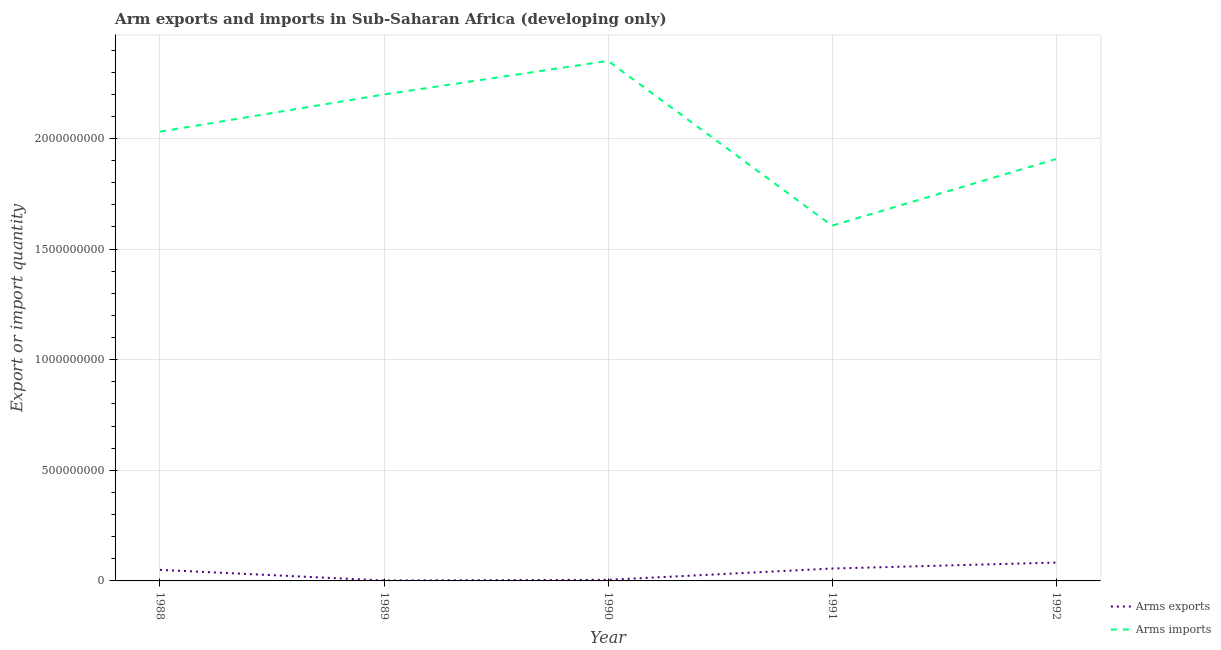Does the line corresponding to arms exports intersect with the line corresponding to arms imports?
Provide a succinct answer. No. Is the number of lines equal to the number of legend labels?
Offer a terse response. Yes. What is the arms exports in 1989?
Your response must be concise. 2.00e+06. Across all years, what is the maximum arms exports?
Keep it short and to the point. 8.30e+07. Across all years, what is the minimum arms imports?
Offer a very short reply. 1.61e+09. In which year was the arms imports maximum?
Make the answer very short. 1990. What is the total arms imports in the graph?
Provide a short and direct response. 1.01e+1. What is the difference between the arms exports in 1990 and that in 1991?
Your response must be concise. -5.10e+07. What is the difference between the arms exports in 1988 and the arms imports in 1990?
Keep it short and to the point. -2.30e+09. What is the average arms exports per year?
Keep it short and to the point. 3.92e+07. In the year 1989, what is the difference between the arms exports and arms imports?
Offer a terse response. -2.20e+09. What is the ratio of the arms exports in 1989 to that in 1991?
Your answer should be compact. 0.04. What is the difference between the highest and the second highest arms exports?
Keep it short and to the point. 2.70e+07. What is the difference between the highest and the lowest arms imports?
Offer a terse response. 7.45e+08. In how many years, is the arms imports greater than the average arms imports taken over all years?
Offer a very short reply. 3. Is the sum of the arms exports in 1988 and 1992 greater than the maximum arms imports across all years?
Offer a very short reply. No. How many lines are there?
Provide a short and direct response. 2. Are the values on the major ticks of Y-axis written in scientific E-notation?
Offer a terse response. No. How are the legend labels stacked?
Provide a short and direct response. Vertical. What is the title of the graph?
Provide a succinct answer. Arm exports and imports in Sub-Saharan Africa (developing only). What is the label or title of the X-axis?
Your answer should be compact. Year. What is the label or title of the Y-axis?
Your answer should be compact. Export or import quantity. What is the Export or import quantity in Arms imports in 1988?
Provide a short and direct response. 2.03e+09. What is the Export or import quantity in Arms imports in 1989?
Offer a terse response. 2.20e+09. What is the Export or import quantity in Arms imports in 1990?
Make the answer very short. 2.35e+09. What is the Export or import quantity in Arms exports in 1991?
Provide a succinct answer. 5.60e+07. What is the Export or import quantity of Arms imports in 1991?
Your answer should be compact. 1.61e+09. What is the Export or import quantity in Arms exports in 1992?
Give a very brief answer. 8.30e+07. What is the Export or import quantity of Arms imports in 1992?
Provide a succinct answer. 1.91e+09. Across all years, what is the maximum Export or import quantity in Arms exports?
Your answer should be very brief. 8.30e+07. Across all years, what is the maximum Export or import quantity of Arms imports?
Make the answer very short. 2.35e+09. Across all years, what is the minimum Export or import quantity in Arms imports?
Offer a terse response. 1.61e+09. What is the total Export or import quantity of Arms exports in the graph?
Ensure brevity in your answer.  1.96e+08. What is the total Export or import quantity in Arms imports in the graph?
Ensure brevity in your answer.  1.01e+1. What is the difference between the Export or import quantity of Arms exports in 1988 and that in 1989?
Your answer should be very brief. 4.80e+07. What is the difference between the Export or import quantity of Arms imports in 1988 and that in 1989?
Offer a terse response. -1.68e+08. What is the difference between the Export or import quantity of Arms exports in 1988 and that in 1990?
Ensure brevity in your answer.  4.50e+07. What is the difference between the Export or import quantity of Arms imports in 1988 and that in 1990?
Provide a short and direct response. -3.20e+08. What is the difference between the Export or import quantity of Arms exports in 1988 and that in 1991?
Your answer should be very brief. -6.00e+06. What is the difference between the Export or import quantity in Arms imports in 1988 and that in 1991?
Ensure brevity in your answer.  4.25e+08. What is the difference between the Export or import quantity in Arms exports in 1988 and that in 1992?
Your answer should be compact. -3.30e+07. What is the difference between the Export or import quantity in Arms imports in 1988 and that in 1992?
Your response must be concise. 1.24e+08. What is the difference between the Export or import quantity in Arms exports in 1989 and that in 1990?
Offer a very short reply. -3.00e+06. What is the difference between the Export or import quantity of Arms imports in 1989 and that in 1990?
Your response must be concise. -1.52e+08. What is the difference between the Export or import quantity in Arms exports in 1989 and that in 1991?
Give a very brief answer. -5.40e+07. What is the difference between the Export or import quantity of Arms imports in 1989 and that in 1991?
Provide a short and direct response. 5.93e+08. What is the difference between the Export or import quantity in Arms exports in 1989 and that in 1992?
Ensure brevity in your answer.  -8.10e+07. What is the difference between the Export or import quantity of Arms imports in 1989 and that in 1992?
Offer a very short reply. 2.92e+08. What is the difference between the Export or import quantity in Arms exports in 1990 and that in 1991?
Provide a succinct answer. -5.10e+07. What is the difference between the Export or import quantity of Arms imports in 1990 and that in 1991?
Provide a succinct answer. 7.45e+08. What is the difference between the Export or import quantity of Arms exports in 1990 and that in 1992?
Give a very brief answer. -7.80e+07. What is the difference between the Export or import quantity of Arms imports in 1990 and that in 1992?
Provide a succinct answer. 4.44e+08. What is the difference between the Export or import quantity of Arms exports in 1991 and that in 1992?
Your response must be concise. -2.70e+07. What is the difference between the Export or import quantity in Arms imports in 1991 and that in 1992?
Provide a succinct answer. -3.01e+08. What is the difference between the Export or import quantity of Arms exports in 1988 and the Export or import quantity of Arms imports in 1989?
Ensure brevity in your answer.  -2.15e+09. What is the difference between the Export or import quantity of Arms exports in 1988 and the Export or import quantity of Arms imports in 1990?
Make the answer very short. -2.30e+09. What is the difference between the Export or import quantity of Arms exports in 1988 and the Export or import quantity of Arms imports in 1991?
Offer a very short reply. -1.56e+09. What is the difference between the Export or import quantity in Arms exports in 1988 and the Export or import quantity in Arms imports in 1992?
Offer a very short reply. -1.86e+09. What is the difference between the Export or import quantity of Arms exports in 1989 and the Export or import quantity of Arms imports in 1990?
Your response must be concise. -2.35e+09. What is the difference between the Export or import quantity in Arms exports in 1989 and the Export or import quantity in Arms imports in 1991?
Give a very brief answer. -1.60e+09. What is the difference between the Export or import quantity in Arms exports in 1989 and the Export or import quantity in Arms imports in 1992?
Offer a very short reply. -1.90e+09. What is the difference between the Export or import quantity of Arms exports in 1990 and the Export or import quantity of Arms imports in 1991?
Your response must be concise. -1.60e+09. What is the difference between the Export or import quantity in Arms exports in 1990 and the Export or import quantity in Arms imports in 1992?
Offer a terse response. -1.90e+09. What is the difference between the Export or import quantity of Arms exports in 1991 and the Export or import quantity of Arms imports in 1992?
Make the answer very short. -1.85e+09. What is the average Export or import quantity in Arms exports per year?
Provide a short and direct response. 3.92e+07. What is the average Export or import quantity of Arms imports per year?
Offer a very short reply. 2.02e+09. In the year 1988, what is the difference between the Export or import quantity of Arms exports and Export or import quantity of Arms imports?
Your answer should be compact. -1.98e+09. In the year 1989, what is the difference between the Export or import quantity of Arms exports and Export or import quantity of Arms imports?
Your response must be concise. -2.20e+09. In the year 1990, what is the difference between the Export or import quantity in Arms exports and Export or import quantity in Arms imports?
Give a very brief answer. -2.35e+09. In the year 1991, what is the difference between the Export or import quantity of Arms exports and Export or import quantity of Arms imports?
Give a very brief answer. -1.55e+09. In the year 1992, what is the difference between the Export or import quantity of Arms exports and Export or import quantity of Arms imports?
Give a very brief answer. -1.82e+09. What is the ratio of the Export or import quantity of Arms imports in 1988 to that in 1989?
Offer a terse response. 0.92. What is the ratio of the Export or import quantity in Arms imports in 1988 to that in 1990?
Make the answer very short. 0.86. What is the ratio of the Export or import quantity of Arms exports in 1988 to that in 1991?
Your answer should be compact. 0.89. What is the ratio of the Export or import quantity of Arms imports in 1988 to that in 1991?
Offer a terse response. 1.26. What is the ratio of the Export or import quantity of Arms exports in 1988 to that in 1992?
Ensure brevity in your answer.  0.6. What is the ratio of the Export or import quantity of Arms imports in 1988 to that in 1992?
Make the answer very short. 1.06. What is the ratio of the Export or import quantity of Arms exports in 1989 to that in 1990?
Your answer should be very brief. 0.4. What is the ratio of the Export or import quantity in Arms imports in 1989 to that in 1990?
Ensure brevity in your answer.  0.94. What is the ratio of the Export or import quantity in Arms exports in 1989 to that in 1991?
Your response must be concise. 0.04. What is the ratio of the Export or import quantity of Arms imports in 1989 to that in 1991?
Give a very brief answer. 1.37. What is the ratio of the Export or import quantity of Arms exports in 1989 to that in 1992?
Your answer should be very brief. 0.02. What is the ratio of the Export or import quantity of Arms imports in 1989 to that in 1992?
Ensure brevity in your answer.  1.15. What is the ratio of the Export or import quantity of Arms exports in 1990 to that in 1991?
Make the answer very short. 0.09. What is the ratio of the Export or import quantity in Arms imports in 1990 to that in 1991?
Provide a succinct answer. 1.46. What is the ratio of the Export or import quantity in Arms exports in 1990 to that in 1992?
Your response must be concise. 0.06. What is the ratio of the Export or import quantity of Arms imports in 1990 to that in 1992?
Offer a terse response. 1.23. What is the ratio of the Export or import quantity in Arms exports in 1991 to that in 1992?
Give a very brief answer. 0.67. What is the ratio of the Export or import quantity of Arms imports in 1991 to that in 1992?
Offer a very short reply. 0.84. What is the difference between the highest and the second highest Export or import quantity of Arms exports?
Ensure brevity in your answer.  2.70e+07. What is the difference between the highest and the second highest Export or import quantity of Arms imports?
Ensure brevity in your answer.  1.52e+08. What is the difference between the highest and the lowest Export or import quantity of Arms exports?
Offer a very short reply. 8.10e+07. What is the difference between the highest and the lowest Export or import quantity of Arms imports?
Your answer should be compact. 7.45e+08. 